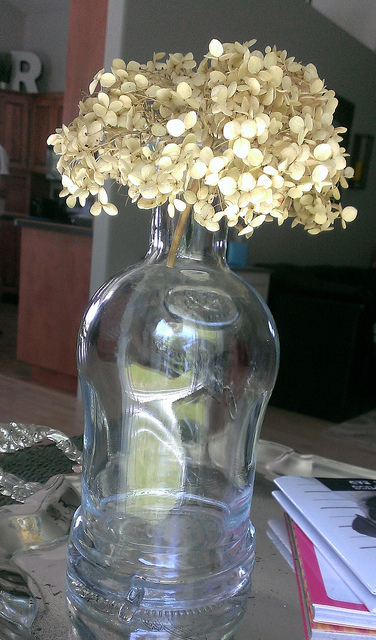Please identify all text content in this image. R 